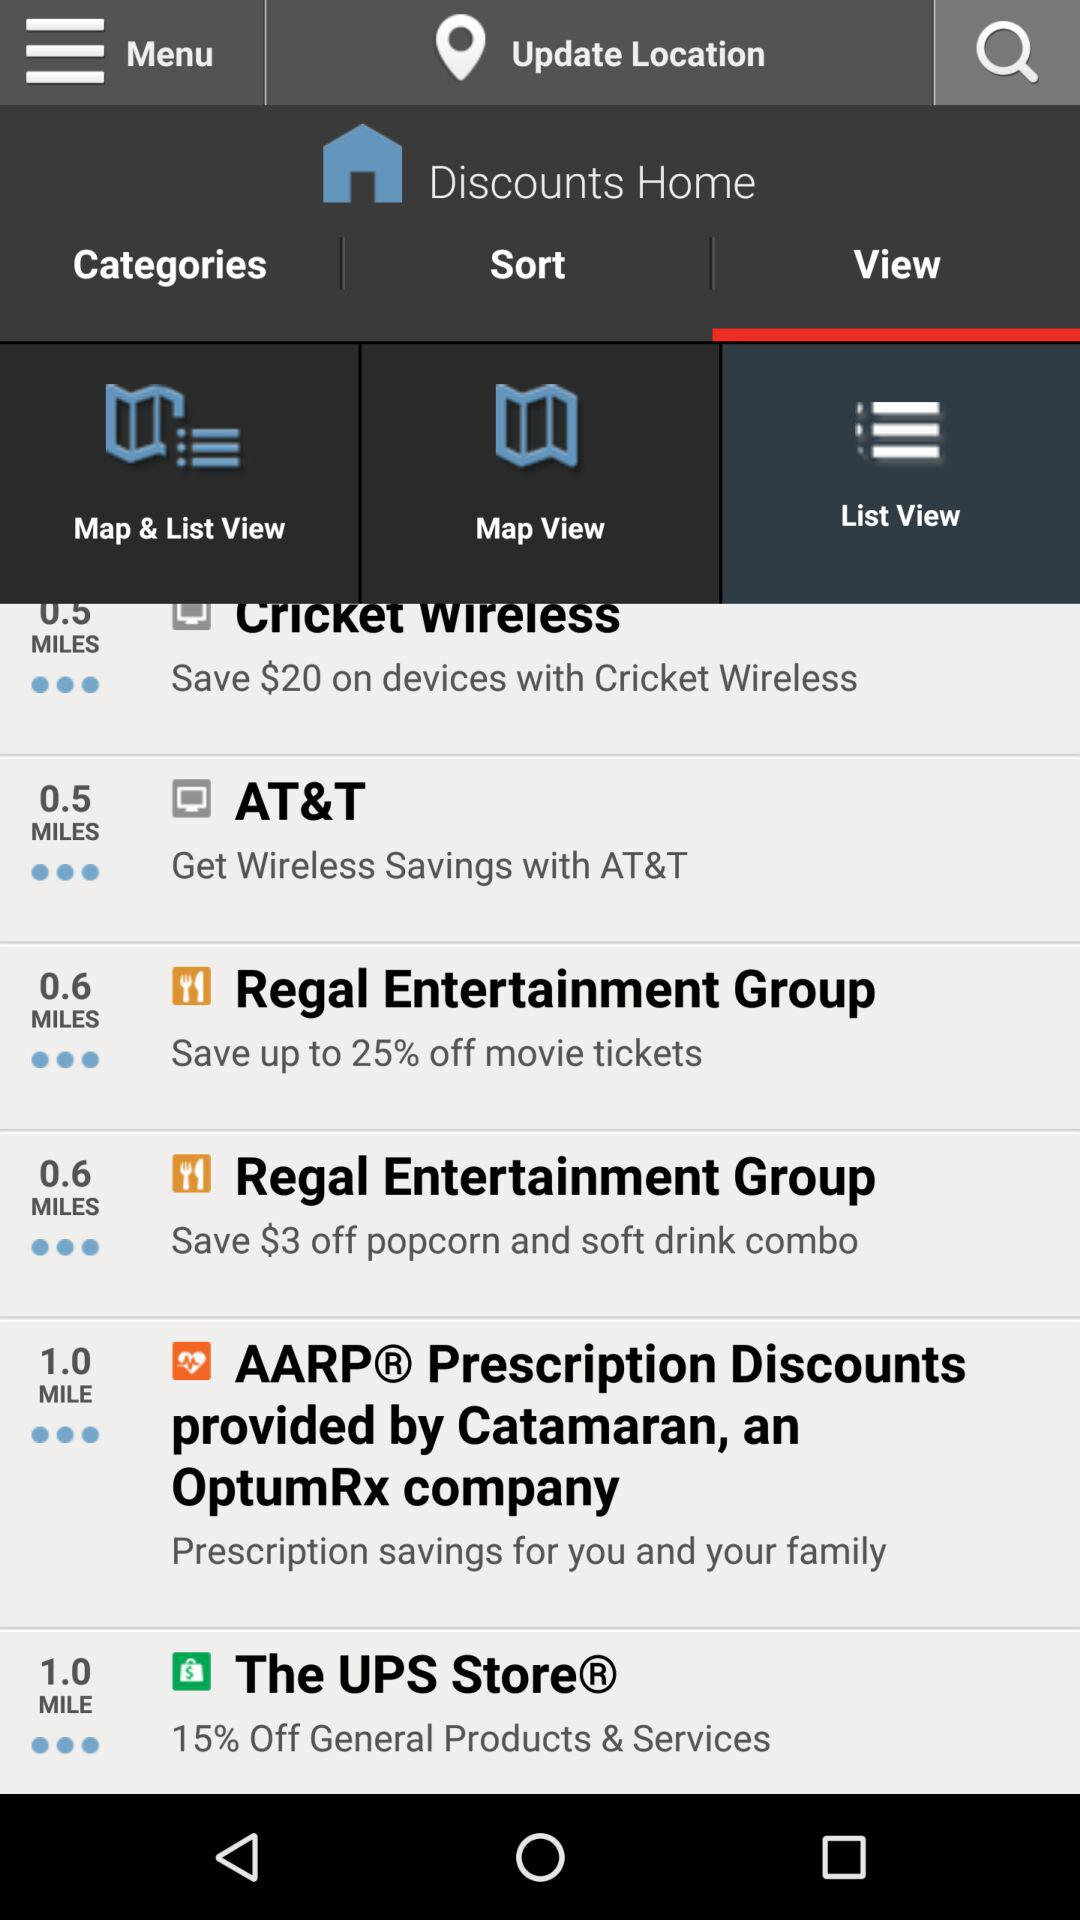Which option is selected? The selected options are "View" and "List View". 